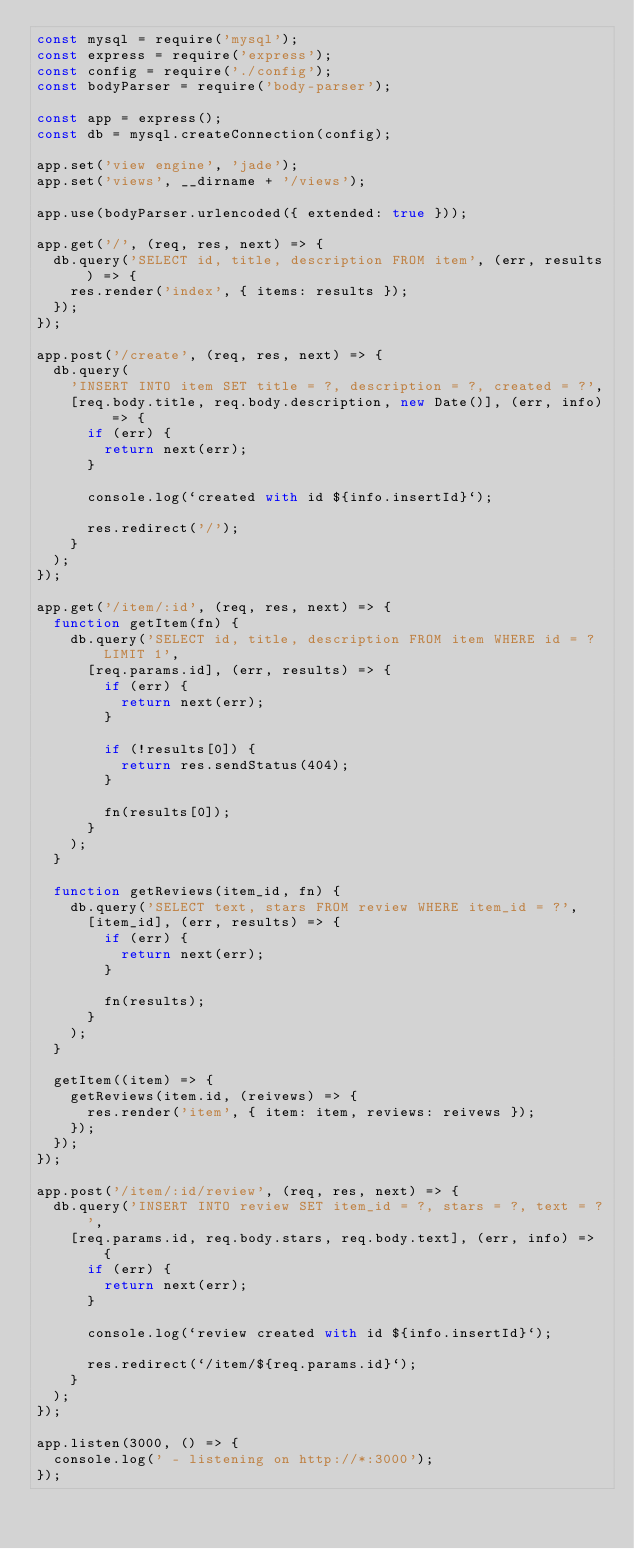Convert code to text. <code><loc_0><loc_0><loc_500><loc_500><_JavaScript_>const mysql = require('mysql');
const express = require('express');
const config = require('./config');
const bodyParser = require('body-parser');

const app = express();
const db = mysql.createConnection(config);

app.set('view engine', 'jade');
app.set('views', __dirname + '/views');

app.use(bodyParser.urlencoded({ extended: true }));

app.get('/', (req, res, next) => {
  db.query('SELECT id, title, description FROM item', (err, results) => {
    res.render('index', { items: results });
  });
});

app.post('/create', (req, res, next) => {
  db.query(
    'INSERT INTO item SET title = ?, description = ?, created = ?',
    [req.body.title, req.body.description, new Date()], (err, info) => {
      if (err) {
        return next(err);
      }

      console.log(`created with id ${info.insertId}`);

      res.redirect('/');
    }
  );
});

app.get('/item/:id', (req, res, next) => {
  function getItem(fn) {
    db.query('SELECT id, title, description FROM item WHERE id = ? LIMIT 1',
      [req.params.id], (err, results) => {
        if (err) {
          return next(err);
        }

        if (!results[0]) {
          return res.sendStatus(404);
        }

        fn(results[0]);
      }
    );
  }

  function getReviews(item_id, fn) {
    db.query('SELECT text, stars FROM review WHERE item_id = ?',
      [item_id], (err, results) => {
        if (err) {
          return next(err);
        }

        fn(results);
      }
    );
  }

  getItem((item) => {
    getReviews(item.id, (reivews) => {
      res.render('item', { item: item, reviews: reivews });
    });
  });
});

app.post('/item/:id/review', (req, res, next) => {
  db.query('INSERT INTO review SET item_id = ?, stars = ?, text = ?',
    [req.params.id, req.body.stars, req.body.text], (err, info) => {
      if (err) {
        return next(err);
      }
      
      console.log(`review created with id ${info.insertId}`);

      res.redirect(`/item/${req.params.id}`);
    }
  );
});

app.listen(3000, () => {
  console.log(' - listening on http://*:3000');
});
</code> 